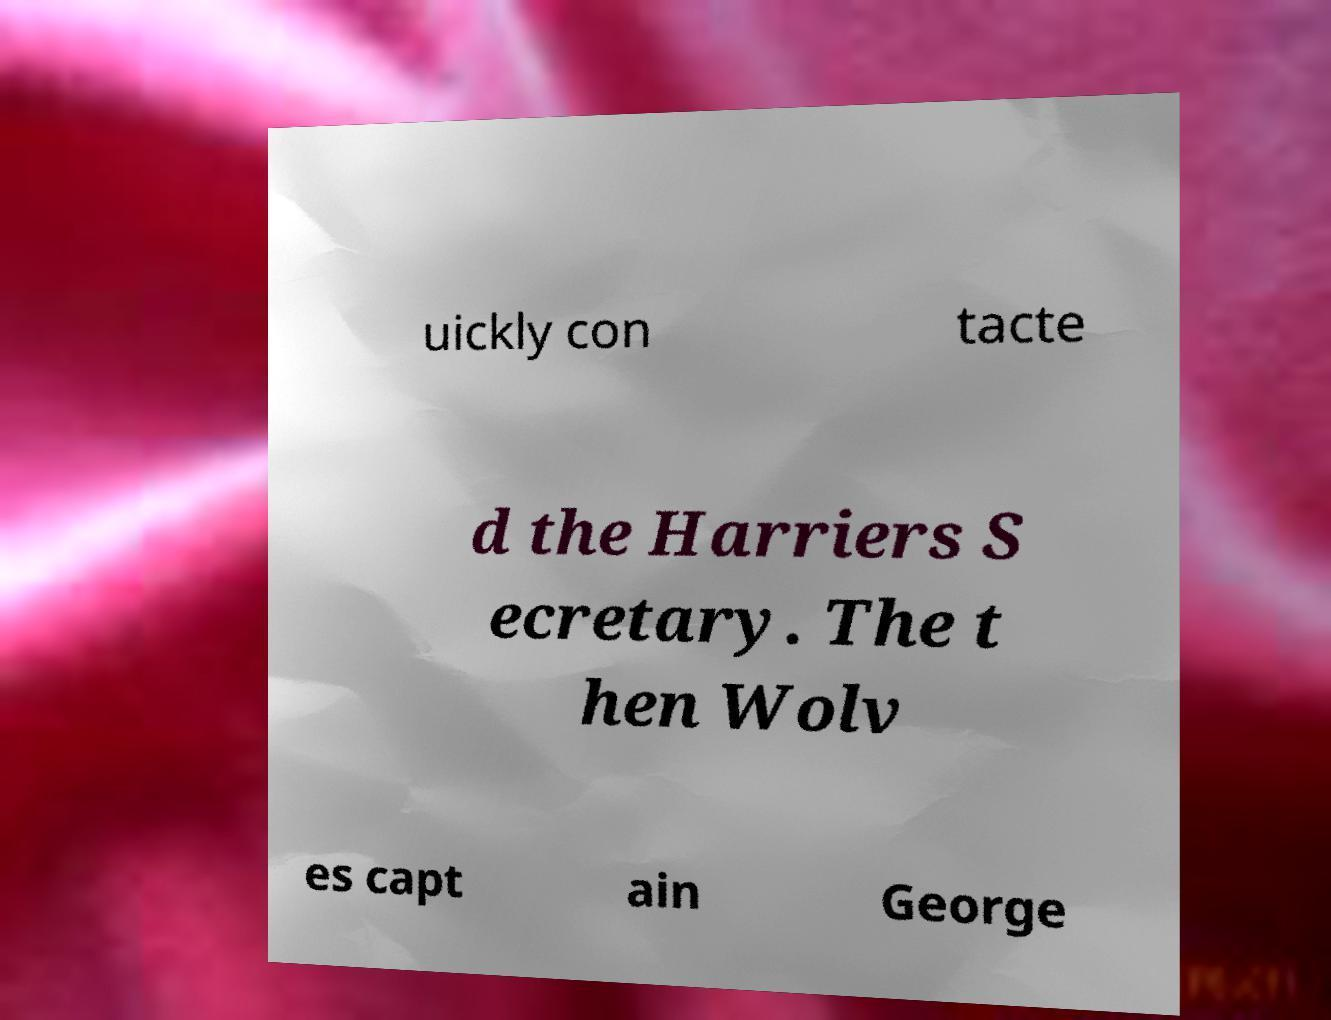I need the written content from this picture converted into text. Can you do that? uickly con tacte d the Harriers S ecretary. The t hen Wolv es capt ain George 